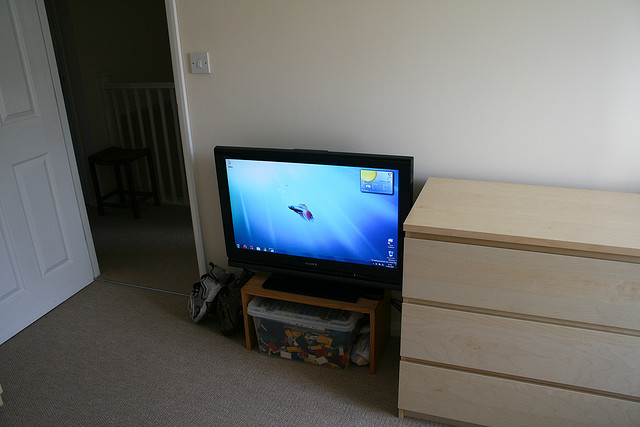<image>What satellite provider is on the screen? It's unclear what satellite provider is on the screen. It can be Direct TV or none. What satellite provider is on the screen? I don't know the satellite provider that is on the screen. It is not possible to determine from the image. 